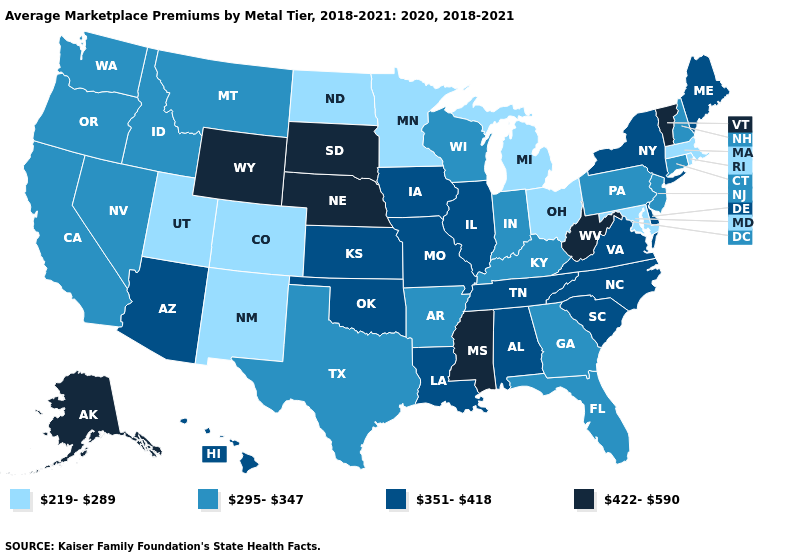What is the value of Texas?
Give a very brief answer. 295-347. What is the value of Utah?
Quick response, please. 219-289. Does Wisconsin have a lower value than Florida?
Keep it brief. No. What is the value of Alaska?
Answer briefly. 422-590. Which states have the lowest value in the USA?
Keep it brief. Colorado, Maryland, Massachusetts, Michigan, Minnesota, New Mexico, North Dakota, Ohio, Rhode Island, Utah. Among the states that border West Virginia , which have the highest value?
Short answer required. Virginia. Name the states that have a value in the range 295-347?
Answer briefly. Arkansas, California, Connecticut, Florida, Georgia, Idaho, Indiana, Kentucky, Montana, Nevada, New Hampshire, New Jersey, Oregon, Pennsylvania, Texas, Washington, Wisconsin. Is the legend a continuous bar?
Keep it brief. No. Does Arizona have the highest value in the West?
Quick response, please. No. Does Massachusetts have the lowest value in the USA?
Be succinct. Yes. What is the highest value in the South ?
Write a very short answer. 422-590. Which states hav the highest value in the South?
Give a very brief answer. Mississippi, West Virginia. Among the states that border West Virginia , does Ohio have the lowest value?
Quick response, please. Yes. Name the states that have a value in the range 295-347?
Keep it brief. Arkansas, California, Connecticut, Florida, Georgia, Idaho, Indiana, Kentucky, Montana, Nevada, New Hampshire, New Jersey, Oregon, Pennsylvania, Texas, Washington, Wisconsin. 